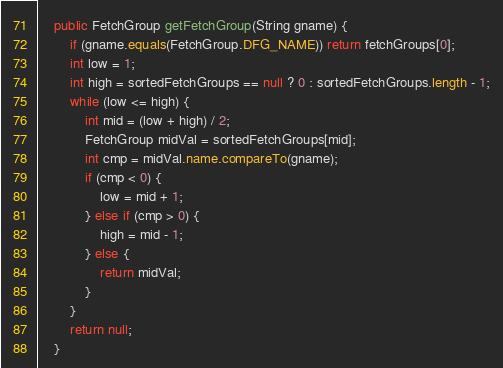<code> <loc_0><loc_0><loc_500><loc_500><_Java_>    public FetchGroup getFetchGroup(String gname) {
        if (gname.equals(FetchGroup.DFG_NAME)) return fetchGroups[0];
        int low = 1;
        int high = sortedFetchGroups == null ? 0 : sortedFetchGroups.length - 1;
        while (low <= high) {
            int mid = (low + high) / 2;
            FetchGroup midVal = sortedFetchGroups[mid];
            int cmp = midVal.name.compareTo(gname);
            if (cmp < 0) {
                low = mid + 1;
            } else if (cmp > 0) {
                high = mid - 1;
            } else {
                return midVal;
            }
        }
        return null;
    }
</code> 